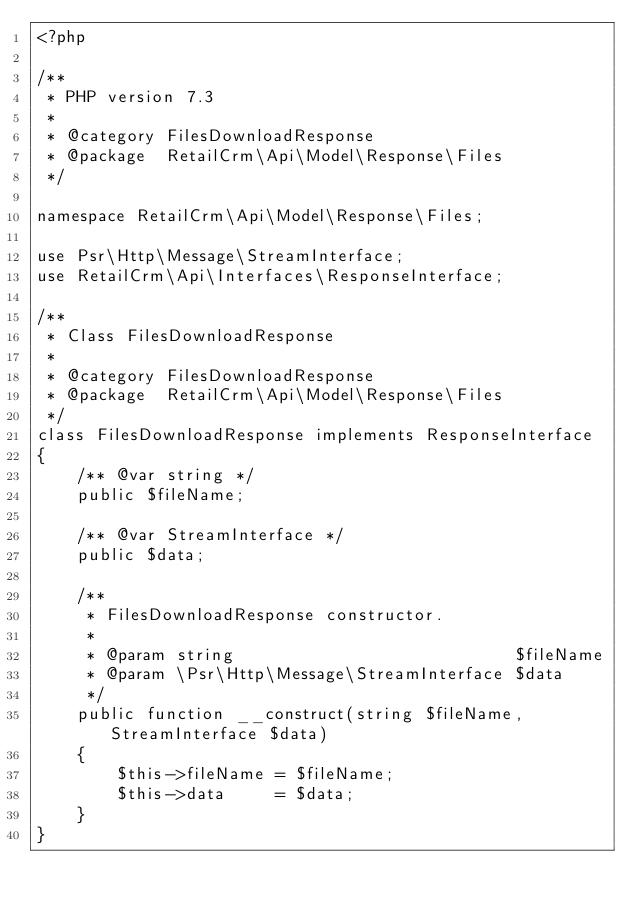Convert code to text. <code><loc_0><loc_0><loc_500><loc_500><_PHP_><?php

/**
 * PHP version 7.3
 *
 * @category FilesDownloadResponse
 * @package  RetailCrm\Api\Model\Response\Files
 */

namespace RetailCrm\Api\Model\Response\Files;

use Psr\Http\Message\StreamInterface;
use RetailCrm\Api\Interfaces\ResponseInterface;

/**
 * Class FilesDownloadResponse
 *
 * @category FilesDownloadResponse
 * @package  RetailCrm\Api\Model\Response\Files
 */
class FilesDownloadResponse implements ResponseInterface
{
    /** @var string */
    public $fileName;

    /** @var StreamInterface */
    public $data;

    /**
     * FilesDownloadResponse constructor.
     *
     * @param string                            $fileName
     * @param \Psr\Http\Message\StreamInterface $data
     */
    public function __construct(string $fileName, StreamInterface $data)
    {
        $this->fileName = $fileName;
        $this->data     = $data;
    }
}
</code> 